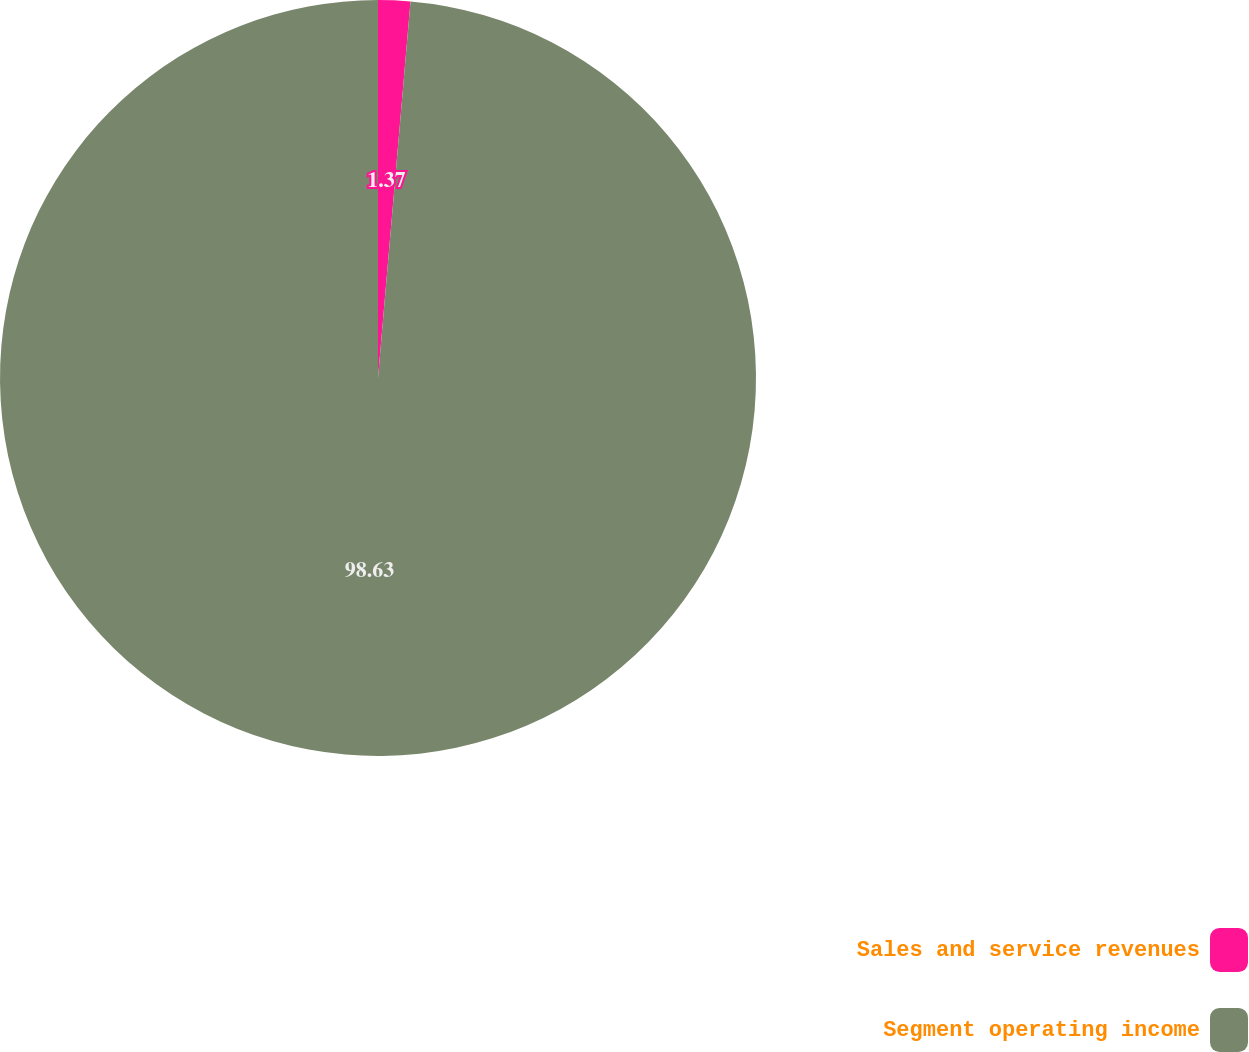Convert chart. <chart><loc_0><loc_0><loc_500><loc_500><pie_chart><fcel>Sales and service revenues<fcel>Segment operating income<nl><fcel>1.37%<fcel>98.63%<nl></chart> 